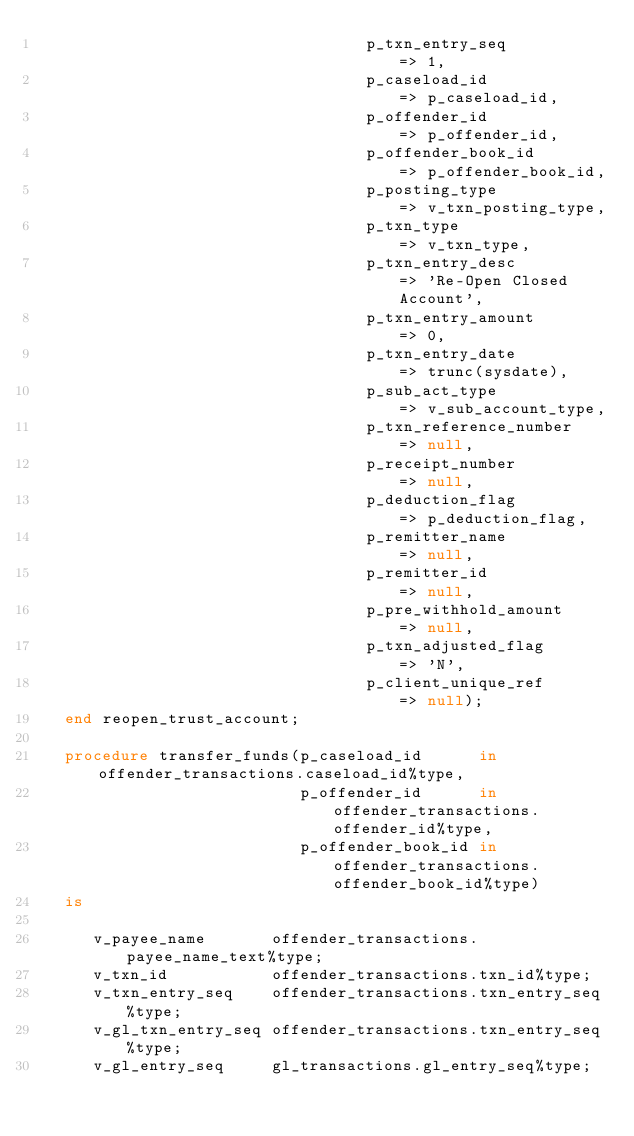Convert code to text. <code><loc_0><loc_0><loc_500><loc_500><_SQL_>                                   p_txn_entry_seq         => 1,
                                   p_caseload_id           => p_caseload_id,
                                   p_offender_id           => p_offender_id,
                                   p_offender_book_id      => p_offender_book_id,
                                   p_posting_type          => v_txn_posting_type,
                                   p_txn_type              => v_txn_type,
                                   p_txn_entry_desc        => 'Re-Open Closed Account',
                                   p_txn_entry_amount      => 0,
                                   p_txn_entry_date        => trunc(sysdate),
                                   p_sub_act_type          => v_sub_account_type,
                                   p_txn_reference_number  => null,
                                   p_receipt_number        => null,
                                   p_deduction_flag        => p_deduction_flag,
                                   p_remitter_name         => null,
                                   p_remitter_id           => null,
                                   p_pre_withhold_amount   => null,
                                   p_txn_adjusted_flag     => 'N',
                                   p_client_unique_ref      => null);
   end reopen_trust_account;

   procedure transfer_funds(p_caseload_id      in offender_transactions.caseload_id%type,
                            p_offender_id      in offender_transactions.offender_id%type,
                            p_offender_book_id in offender_transactions.offender_book_id%type)
   is

      v_payee_name       offender_transactions.payee_name_text%type;
      v_txn_id           offender_transactions.txn_id%type;
      v_txn_entry_seq    offender_transactions.txn_entry_seq%type;
      v_gl_txn_entry_seq offender_transactions.txn_entry_seq%type;
      v_gl_entry_seq     gl_transactions.gl_entry_seq%type;</code> 